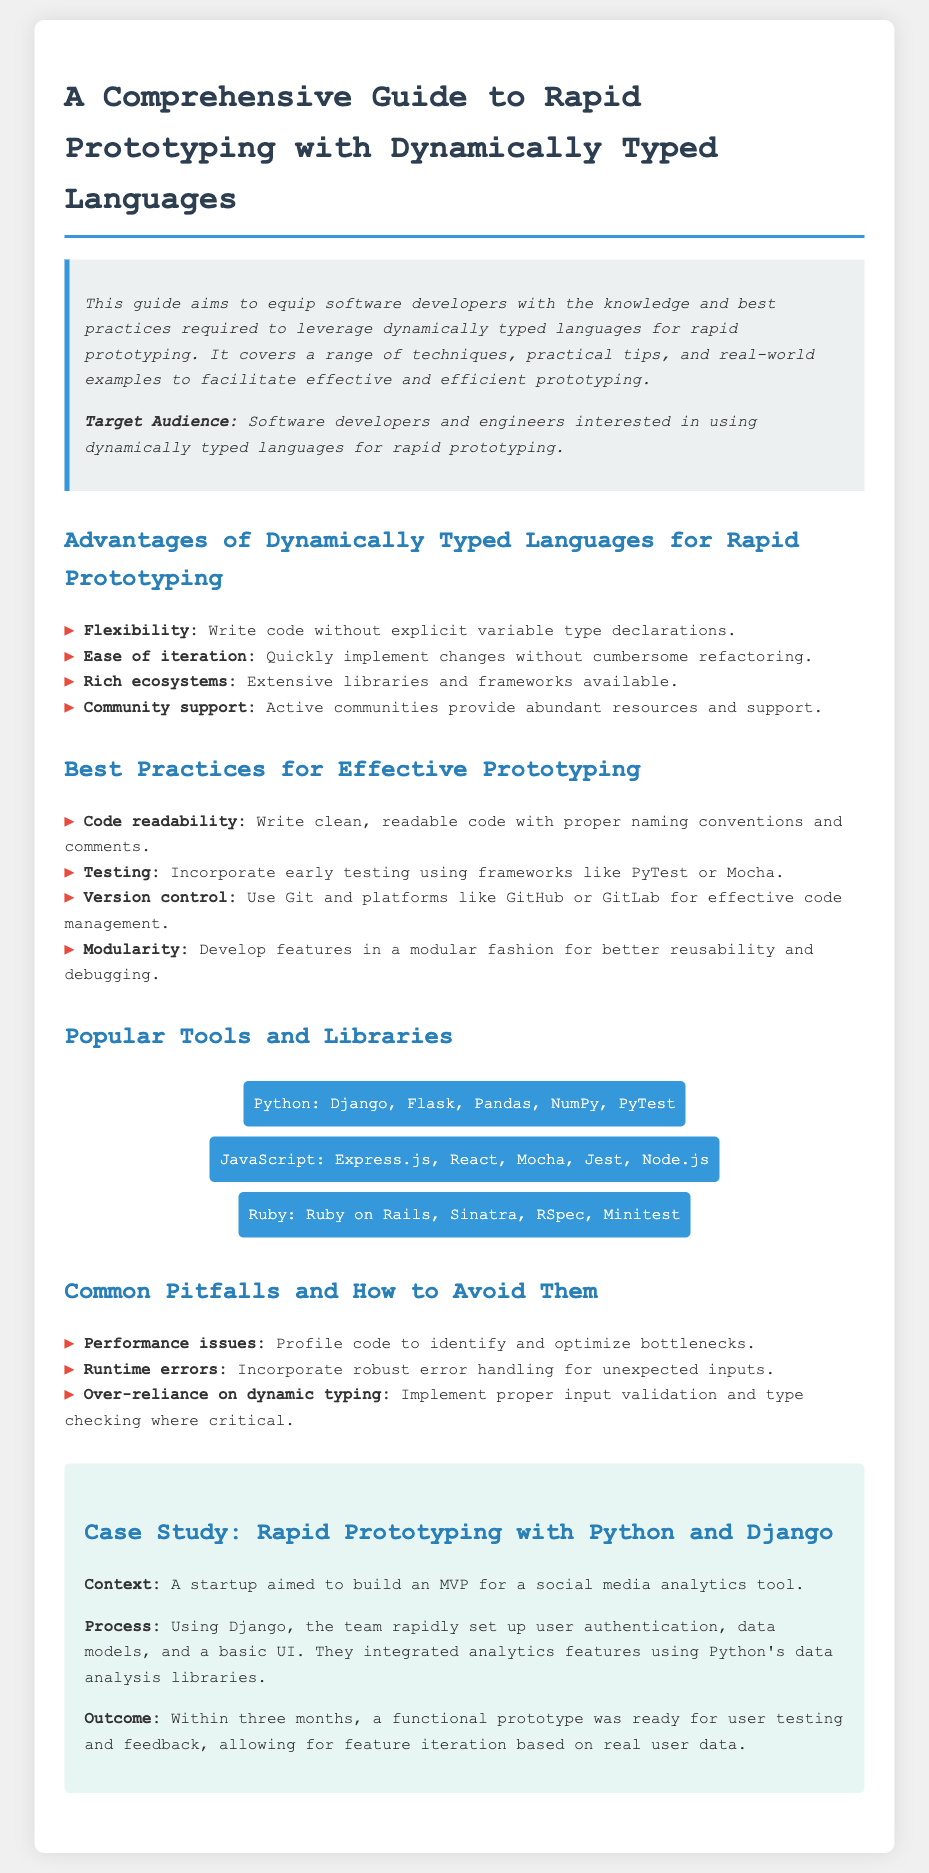What is the target audience of the guide? The guide specifies that the target audience is software developers and engineers interested in using dynamically typed languages for rapid prototyping.
Answer: Software developers and engineers What are two examples of popular tools for Python? The document lists Django and Flask as examples of popular tools for Python among others.
Answer: Django, Flask What is one advantage of using dynamically typed languages for rapid prototyping? The document highlights flexibility as a significant advantage of dynamically typed languages when prototyping.
Answer: Flexibility Which version control system is recommended in the best practices section? The document suggests using Git as the version control system in the best practices for effective prototyping.
Answer: Git How long did it take to develop the prototype in the case study? The case study indicates that it took three months to develop the functional prototype for user testing.
Answer: Three months What is a common pitfall mentioned in the document? The document mentions performance issues as one of the common pitfalls developers should be aware of.
Answer: Performance issues What is an important aspect of code according to the best practices? The best practices section emphasizes code readability, highlighting the importance of clean, readable code.
Answer: Code readability What is one library listed for JavaScript? Among the tools for JavaScript, Mocha is mentioned as an example of a library available for developers.
Answer: Mocha What feature did the team rapidly set up using Django in the case study? The team quickly established user authentication as one of the features using Django in their MVP process.
Answer: User authentication 